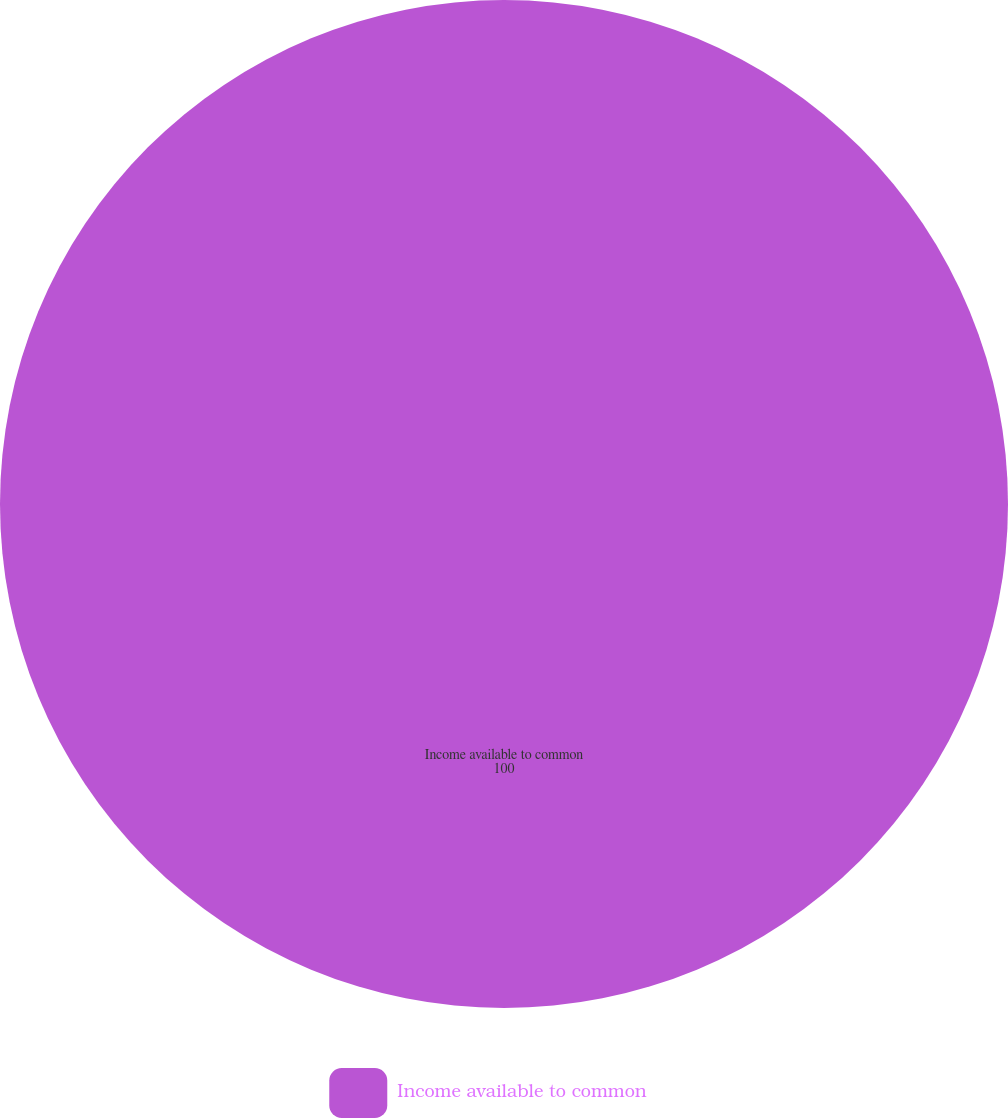Convert chart. <chart><loc_0><loc_0><loc_500><loc_500><pie_chart><fcel>Income available to common<nl><fcel>100.0%<nl></chart> 